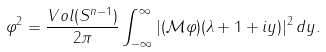Convert formula to latex. <formula><loc_0><loc_0><loc_500><loc_500>\| \varphi \| ^ { 2 } = \frac { V o l ( S ^ { n - 1 } ) } { 2 \pi } \int _ { - \infty } ^ { \infty } | ( \mathcal { M } \varphi ) ( \lambda + 1 + i y ) | ^ { 2 } \, d y .</formula> 